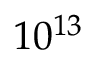Convert formula to latex. <formula><loc_0><loc_0><loc_500><loc_500>1 0 ^ { 1 3 }</formula> 